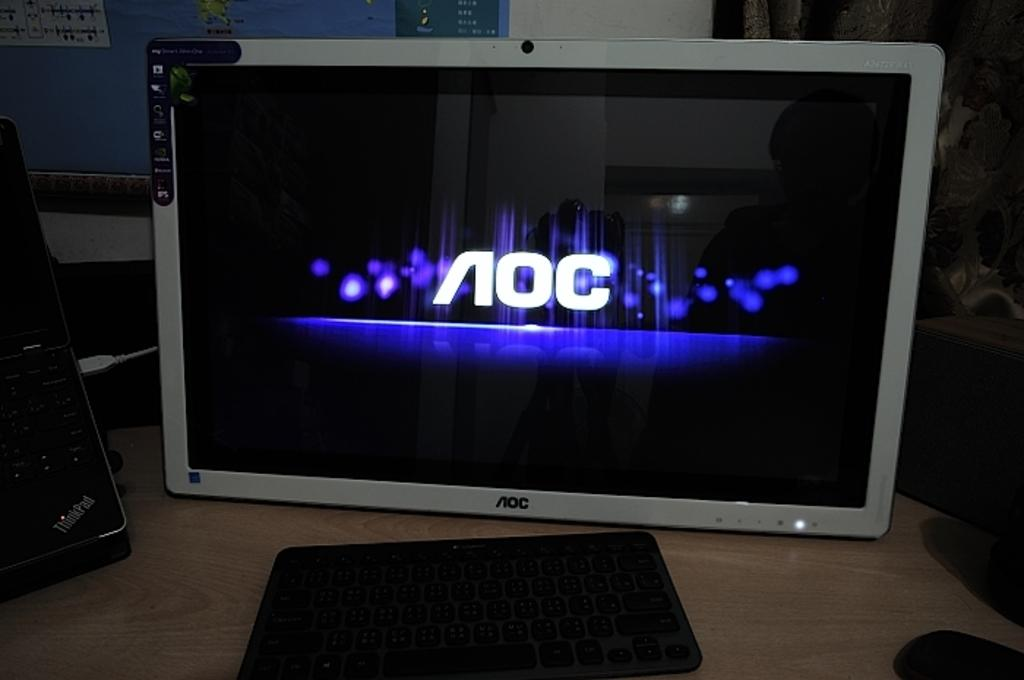What electronic device is visible in the image? There is a monitor in the image. What is being displayed on the monitor? Something is displaying on the monitor. What is used for typing or inputting commands in the image? There is a keyboard in the image. What other objects can be seen on the table in the image? There are other objects on the table. What can be seen in the background of the image? There is a wall in the background of the image. How does the nation transport goods in the image? There is no reference to a nation or goods transportation in the image; it features a monitor, keyboard, and other objects on a table. 